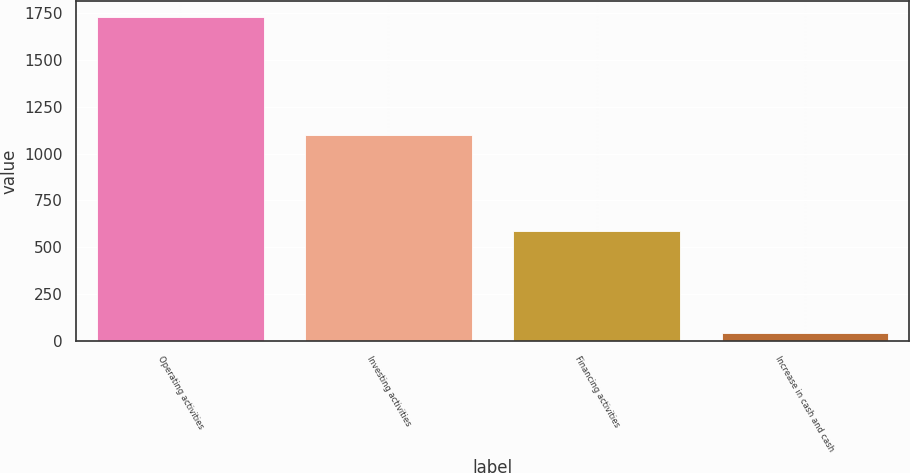Convert chart. <chart><loc_0><loc_0><loc_500><loc_500><bar_chart><fcel>Operating activities<fcel>Investing activities<fcel>Financing activities<fcel>Increase in cash and cash<nl><fcel>1730<fcel>1098<fcel>589<fcel>43<nl></chart> 